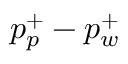Convert formula to latex. <formula><loc_0><loc_0><loc_500><loc_500>p _ { p } ^ { + } - p _ { w } ^ { + }</formula> 